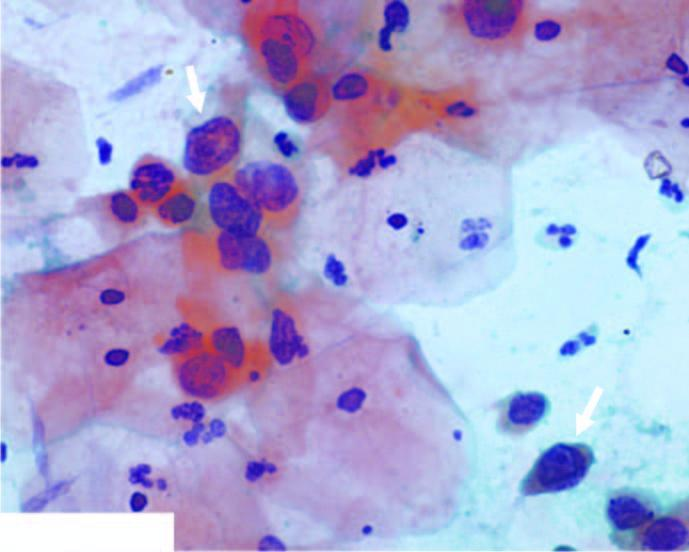does the background show numerous pmns?
Answer the question using a single word or phrase. Yes 